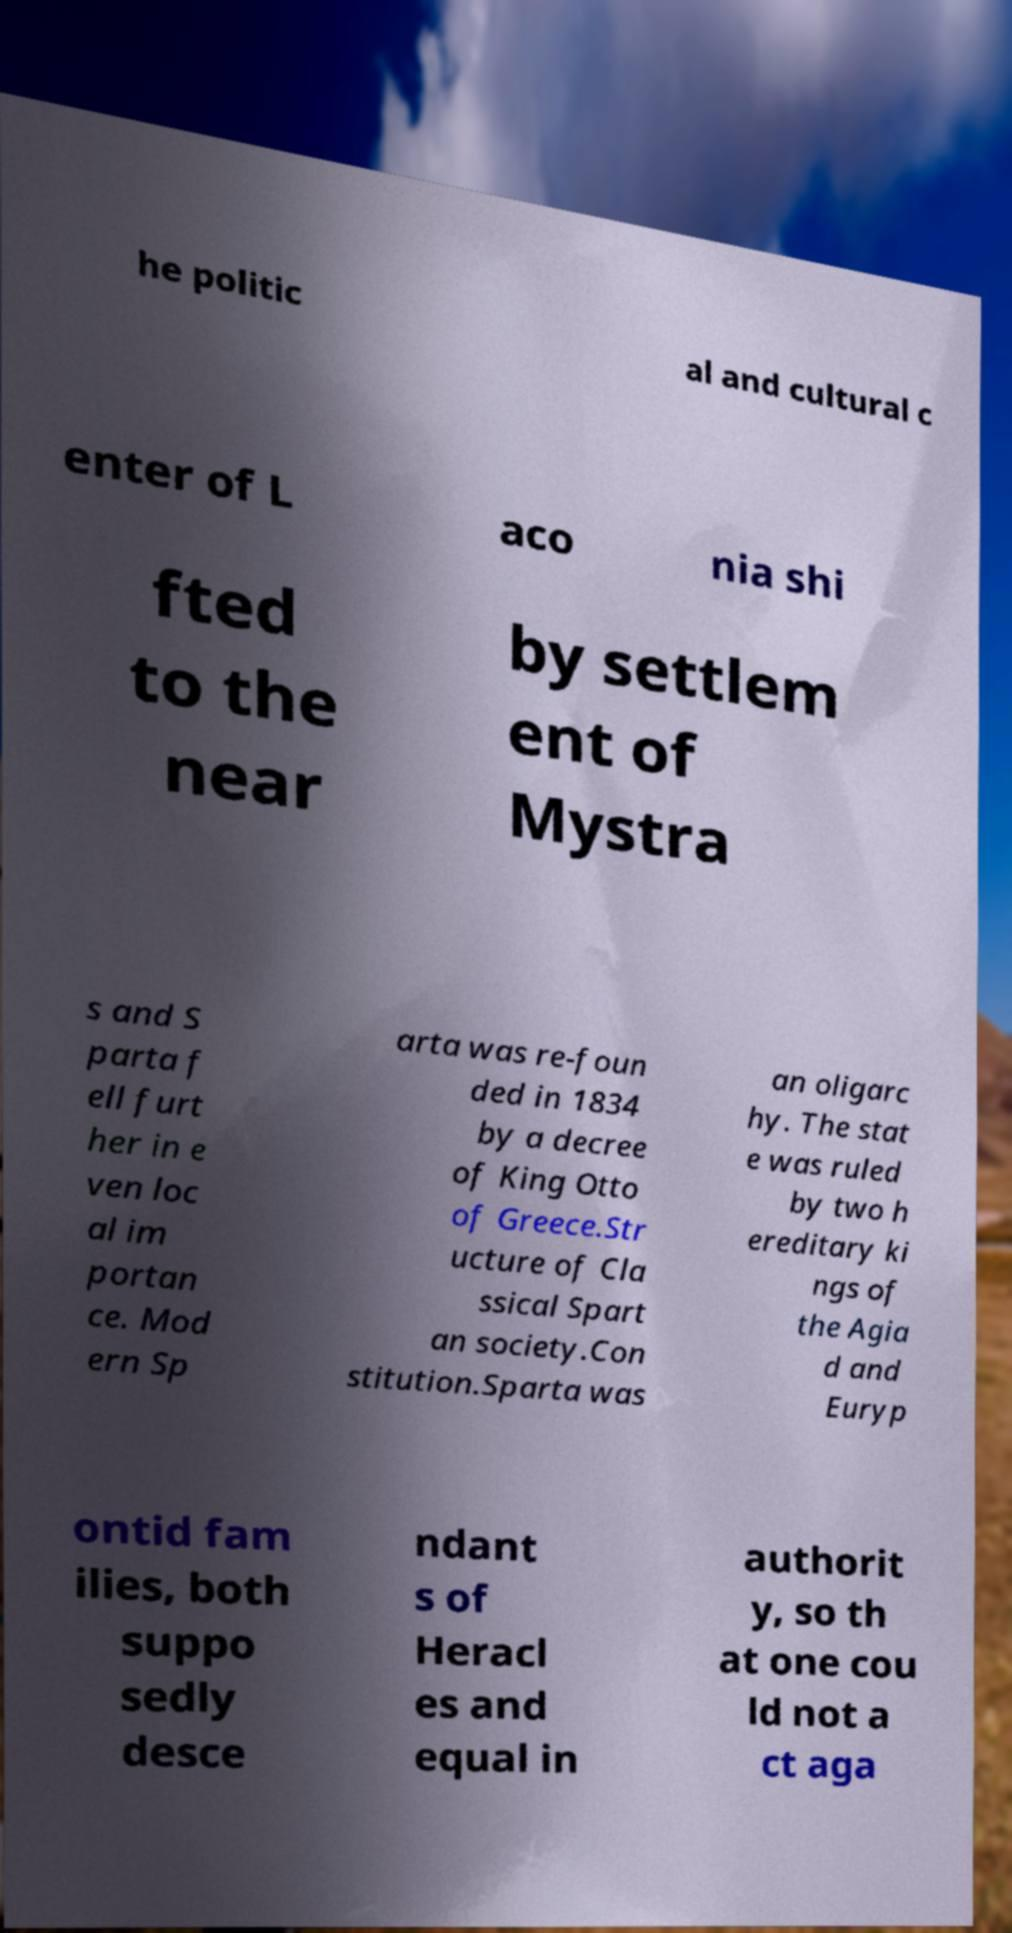Can you read and provide the text displayed in the image?This photo seems to have some interesting text. Can you extract and type it out for me? he politic al and cultural c enter of L aco nia shi fted to the near by settlem ent of Mystra s and S parta f ell furt her in e ven loc al im portan ce. Mod ern Sp arta was re-foun ded in 1834 by a decree of King Otto of Greece.Str ucture of Cla ssical Spart an society.Con stitution.Sparta was an oligarc hy. The stat e was ruled by two h ereditary ki ngs of the Agia d and Euryp ontid fam ilies, both suppo sedly desce ndant s of Heracl es and equal in authorit y, so th at one cou ld not a ct aga 